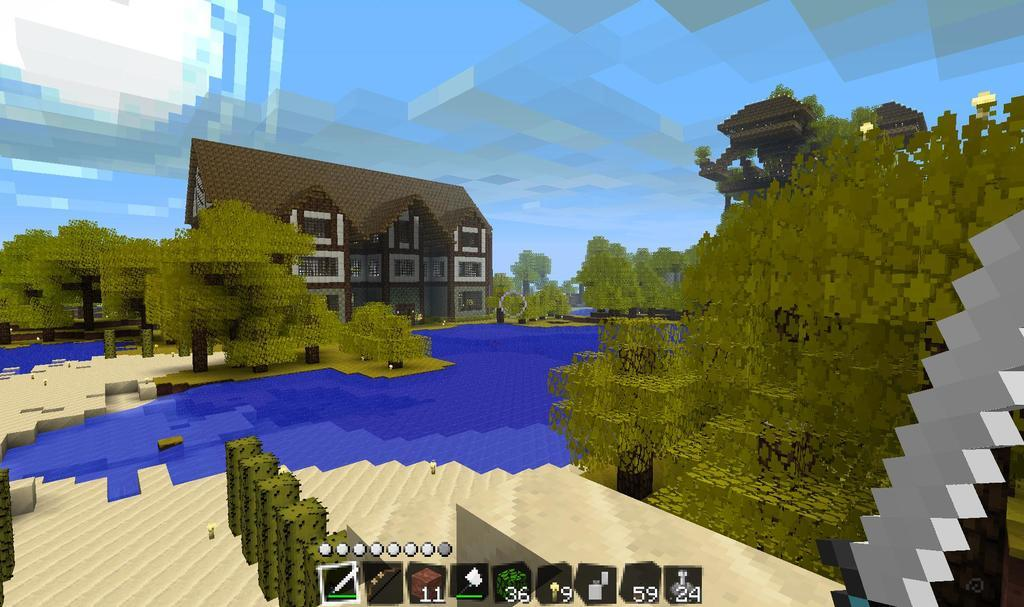What type of structure is present in the image? There is an animated house in the image. What other animated elements can be seen in the image? There are animated plants and trees in the image. What type of honey can be seen dripping from the animated trees in the image? There is no honey present in the image; it features animated trees without any honey. What season is depicted in the image, considering the presence of animated plants and trees? The image does not depict a specific season, as the animated plants and trees do not show any seasonal characteristics. 